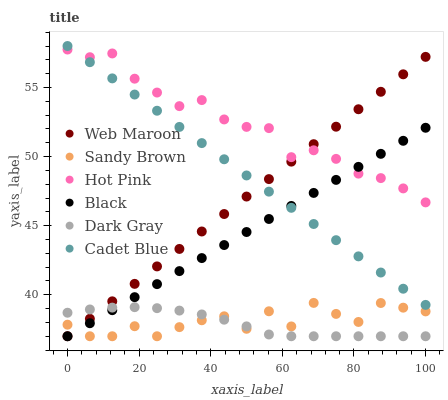Does Dark Gray have the minimum area under the curve?
Answer yes or no. Yes. Does Hot Pink have the maximum area under the curve?
Answer yes or no. Yes. Does Web Maroon have the minimum area under the curve?
Answer yes or no. No. Does Web Maroon have the maximum area under the curve?
Answer yes or no. No. Is Cadet Blue the smoothest?
Answer yes or no. Yes. Is Sandy Brown the roughest?
Answer yes or no. Yes. Is Hot Pink the smoothest?
Answer yes or no. No. Is Hot Pink the roughest?
Answer yes or no. No. Does Web Maroon have the lowest value?
Answer yes or no. Yes. Does Hot Pink have the lowest value?
Answer yes or no. No. Does Cadet Blue have the highest value?
Answer yes or no. Yes. Does Hot Pink have the highest value?
Answer yes or no. No. Is Sandy Brown less than Cadet Blue?
Answer yes or no. Yes. Is Cadet Blue greater than Sandy Brown?
Answer yes or no. Yes. Does Black intersect Dark Gray?
Answer yes or no. Yes. Is Black less than Dark Gray?
Answer yes or no. No. Is Black greater than Dark Gray?
Answer yes or no. No. Does Sandy Brown intersect Cadet Blue?
Answer yes or no. No. 